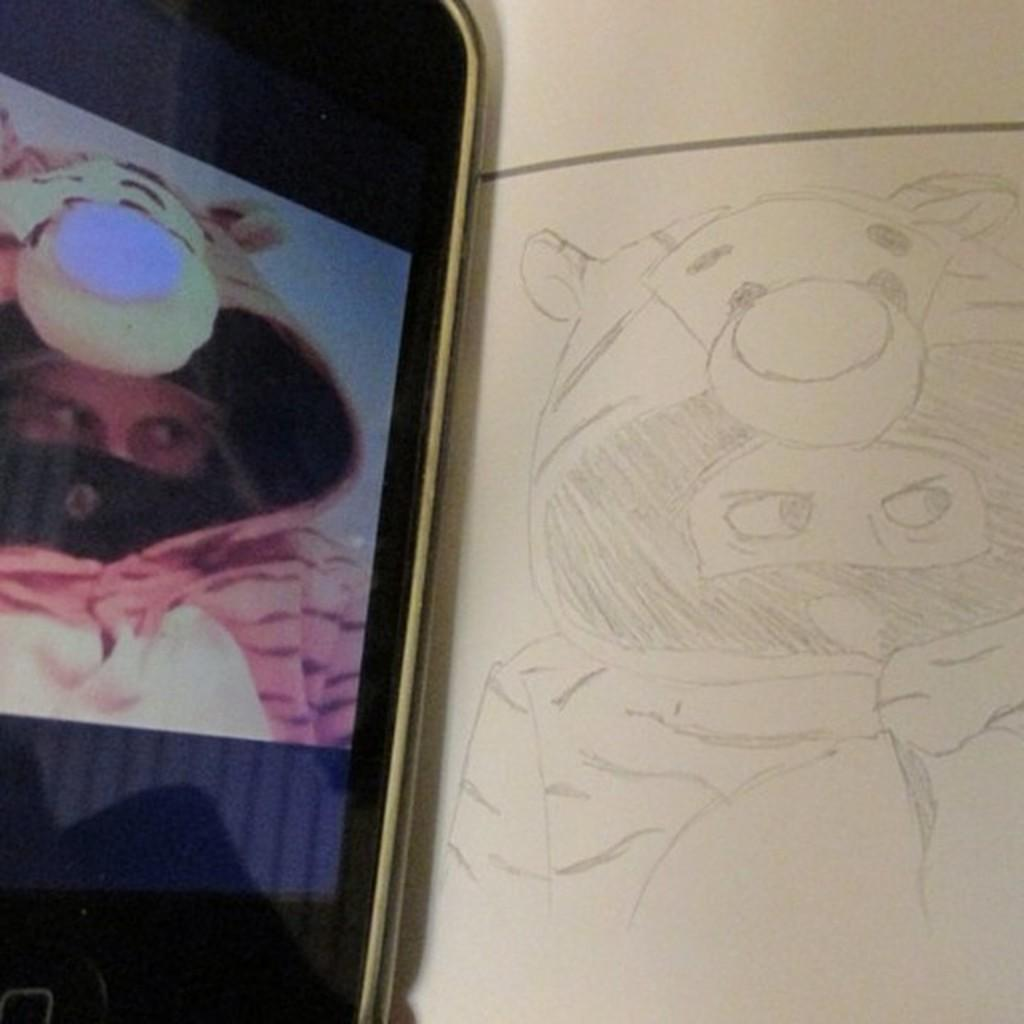What is depicted in the drawing in the image? There is a drawing of a person wearing a costume in the image. What else can be seen in the image besides the drawing? A mobile screen is visible in the image. What is displayed on the mobile screen? On the mobile screen, there is a person wearing a costume at the left side of the image. What type of sock is the person wearing on the right side of the image? There is no person on the right side of the image, and no sock is visible. 